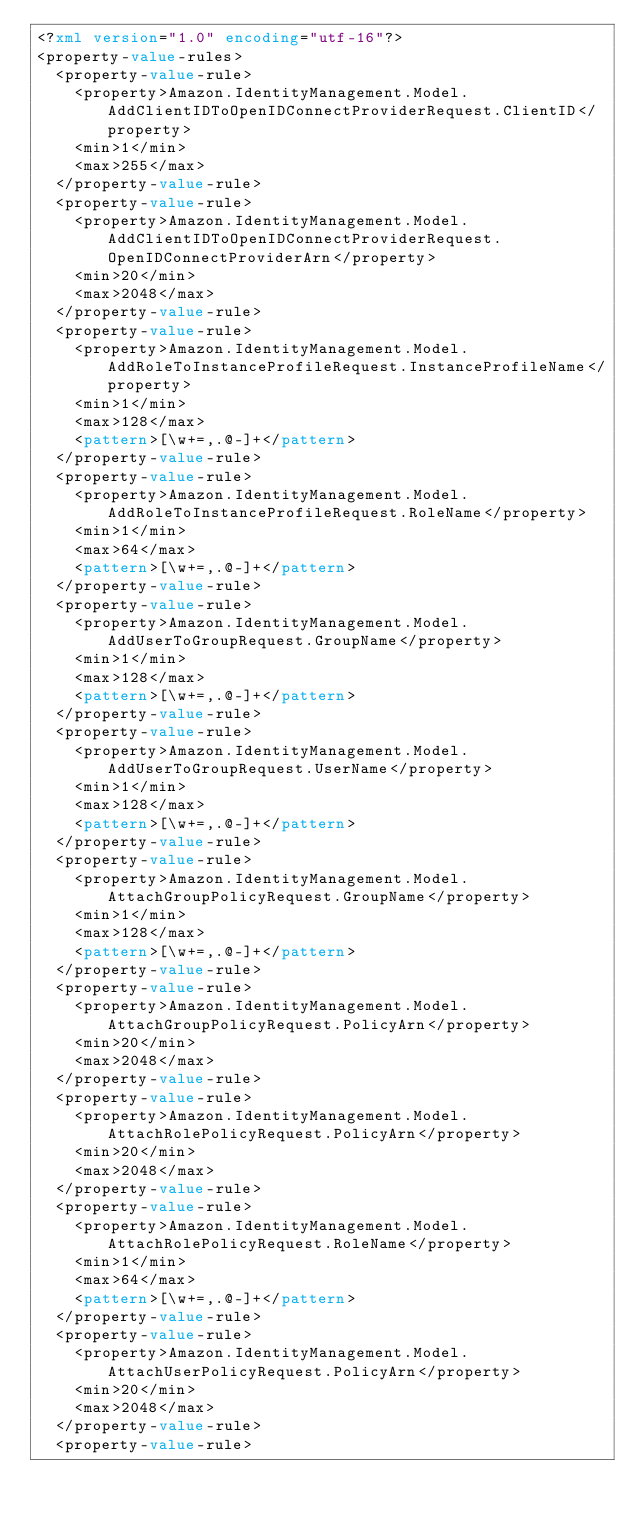Convert code to text. <code><loc_0><loc_0><loc_500><loc_500><_XML_><?xml version="1.0" encoding="utf-16"?>
<property-value-rules>
  <property-value-rule>
    <property>Amazon.IdentityManagement.Model.AddClientIDToOpenIDConnectProviderRequest.ClientID</property>
    <min>1</min>
    <max>255</max>
  </property-value-rule>
  <property-value-rule>
    <property>Amazon.IdentityManagement.Model.AddClientIDToOpenIDConnectProviderRequest.OpenIDConnectProviderArn</property>
    <min>20</min>
    <max>2048</max>
  </property-value-rule>
  <property-value-rule>
    <property>Amazon.IdentityManagement.Model.AddRoleToInstanceProfileRequest.InstanceProfileName</property>
    <min>1</min>
    <max>128</max>
    <pattern>[\w+=,.@-]+</pattern>
  </property-value-rule>
  <property-value-rule>
    <property>Amazon.IdentityManagement.Model.AddRoleToInstanceProfileRequest.RoleName</property>
    <min>1</min>
    <max>64</max>
    <pattern>[\w+=,.@-]+</pattern>
  </property-value-rule>
  <property-value-rule>
    <property>Amazon.IdentityManagement.Model.AddUserToGroupRequest.GroupName</property>
    <min>1</min>
    <max>128</max>
    <pattern>[\w+=,.@-]+</pattern>
  </property-value-rule>
  <property-value-rule>
    <property>Amazon.IdentityManagement.Model.AddUserToGroupRequest.UserName</property>
    <min>1</min>
    <max>128</max>
    <pattern>[\w+=,.@-]+</pattern>
  </property-value-rule>
  <property-value-rule>
    <property>Amazon.IdentityManagement.Model.AttachGroupPolicyRequest.GroupName</property>
    <min>1</min>
    <max>128</max>
    <pattern>[\w+=,.@-]+</pattern>
  </property-value-rule>
  <property-value-rule>
    <property>Amazon.IdentityManagement.Model.AttachGroupPolicyRequest.PolicyArn</property>
    <min>20</min>
    <max>2048</max>
  </property-value-rule>
  <property-value-rule>
    <property>Amazon.IdentityManagement.Model.AttachRolePolicyRequest.PolicyArn</property>
    <min>20</min>
    <max>2048</max>
  </property-value-rule>
  <property-value-rule>
    <property>Amazon.IdentityManagement.Model.AttachRolePolicyRequest.RoleName</property>
    <min>1</min>
    <max>64</max>
    <pattern>[\w+=,.@-]+</pattern>
  </property-value-rule>
  <property-value-rule>
    <property>Amazon.IdentityManagement.Model.AttachUserPolicyRequest.PolicyArn</property>
    <min>20</min>
    <max>2048</max>
  </property-value-rule>
  <property-value-rule></code> 